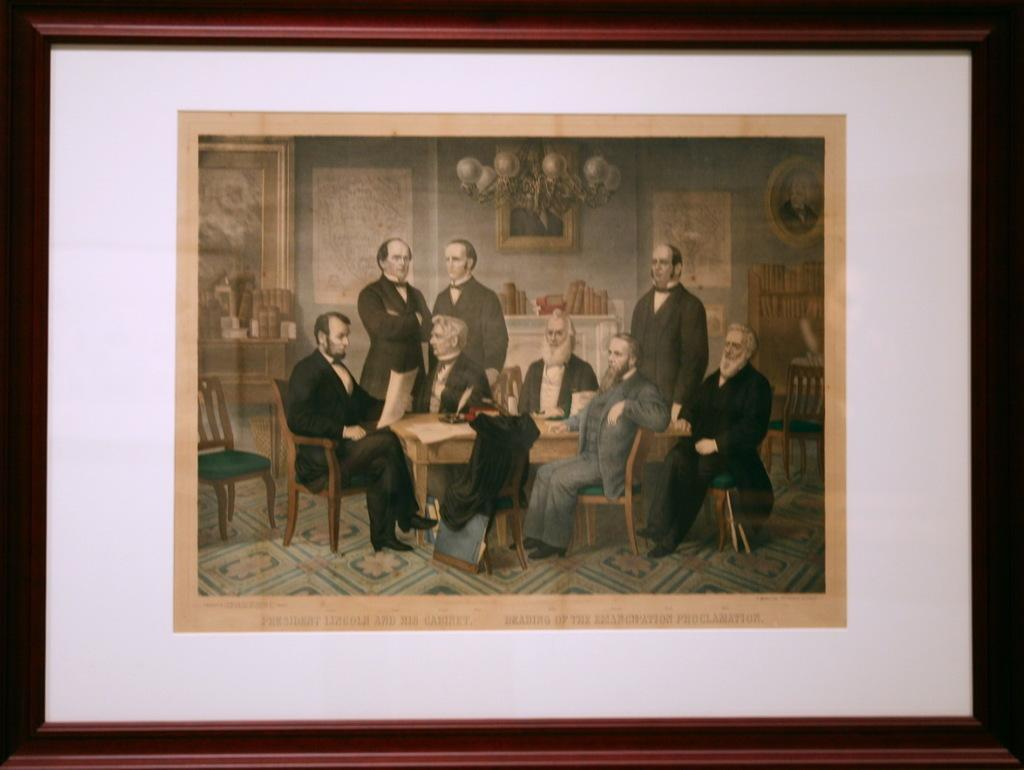What object is the main focus of the image? There is a photo frame in the image. What is depicted inside the photo frame? The photo frame contains humans sitting around a table. What is the color scheme of the image? The image is in black and white. What type of coal is being used to heat the room in the image? There is no coal or indication of heating in the image; it features a photo frame with humans sitting around a table in black and white. How many pies are visible on the table in the image? There are no pies visible in the image; it only shows humans sitting around a table. 